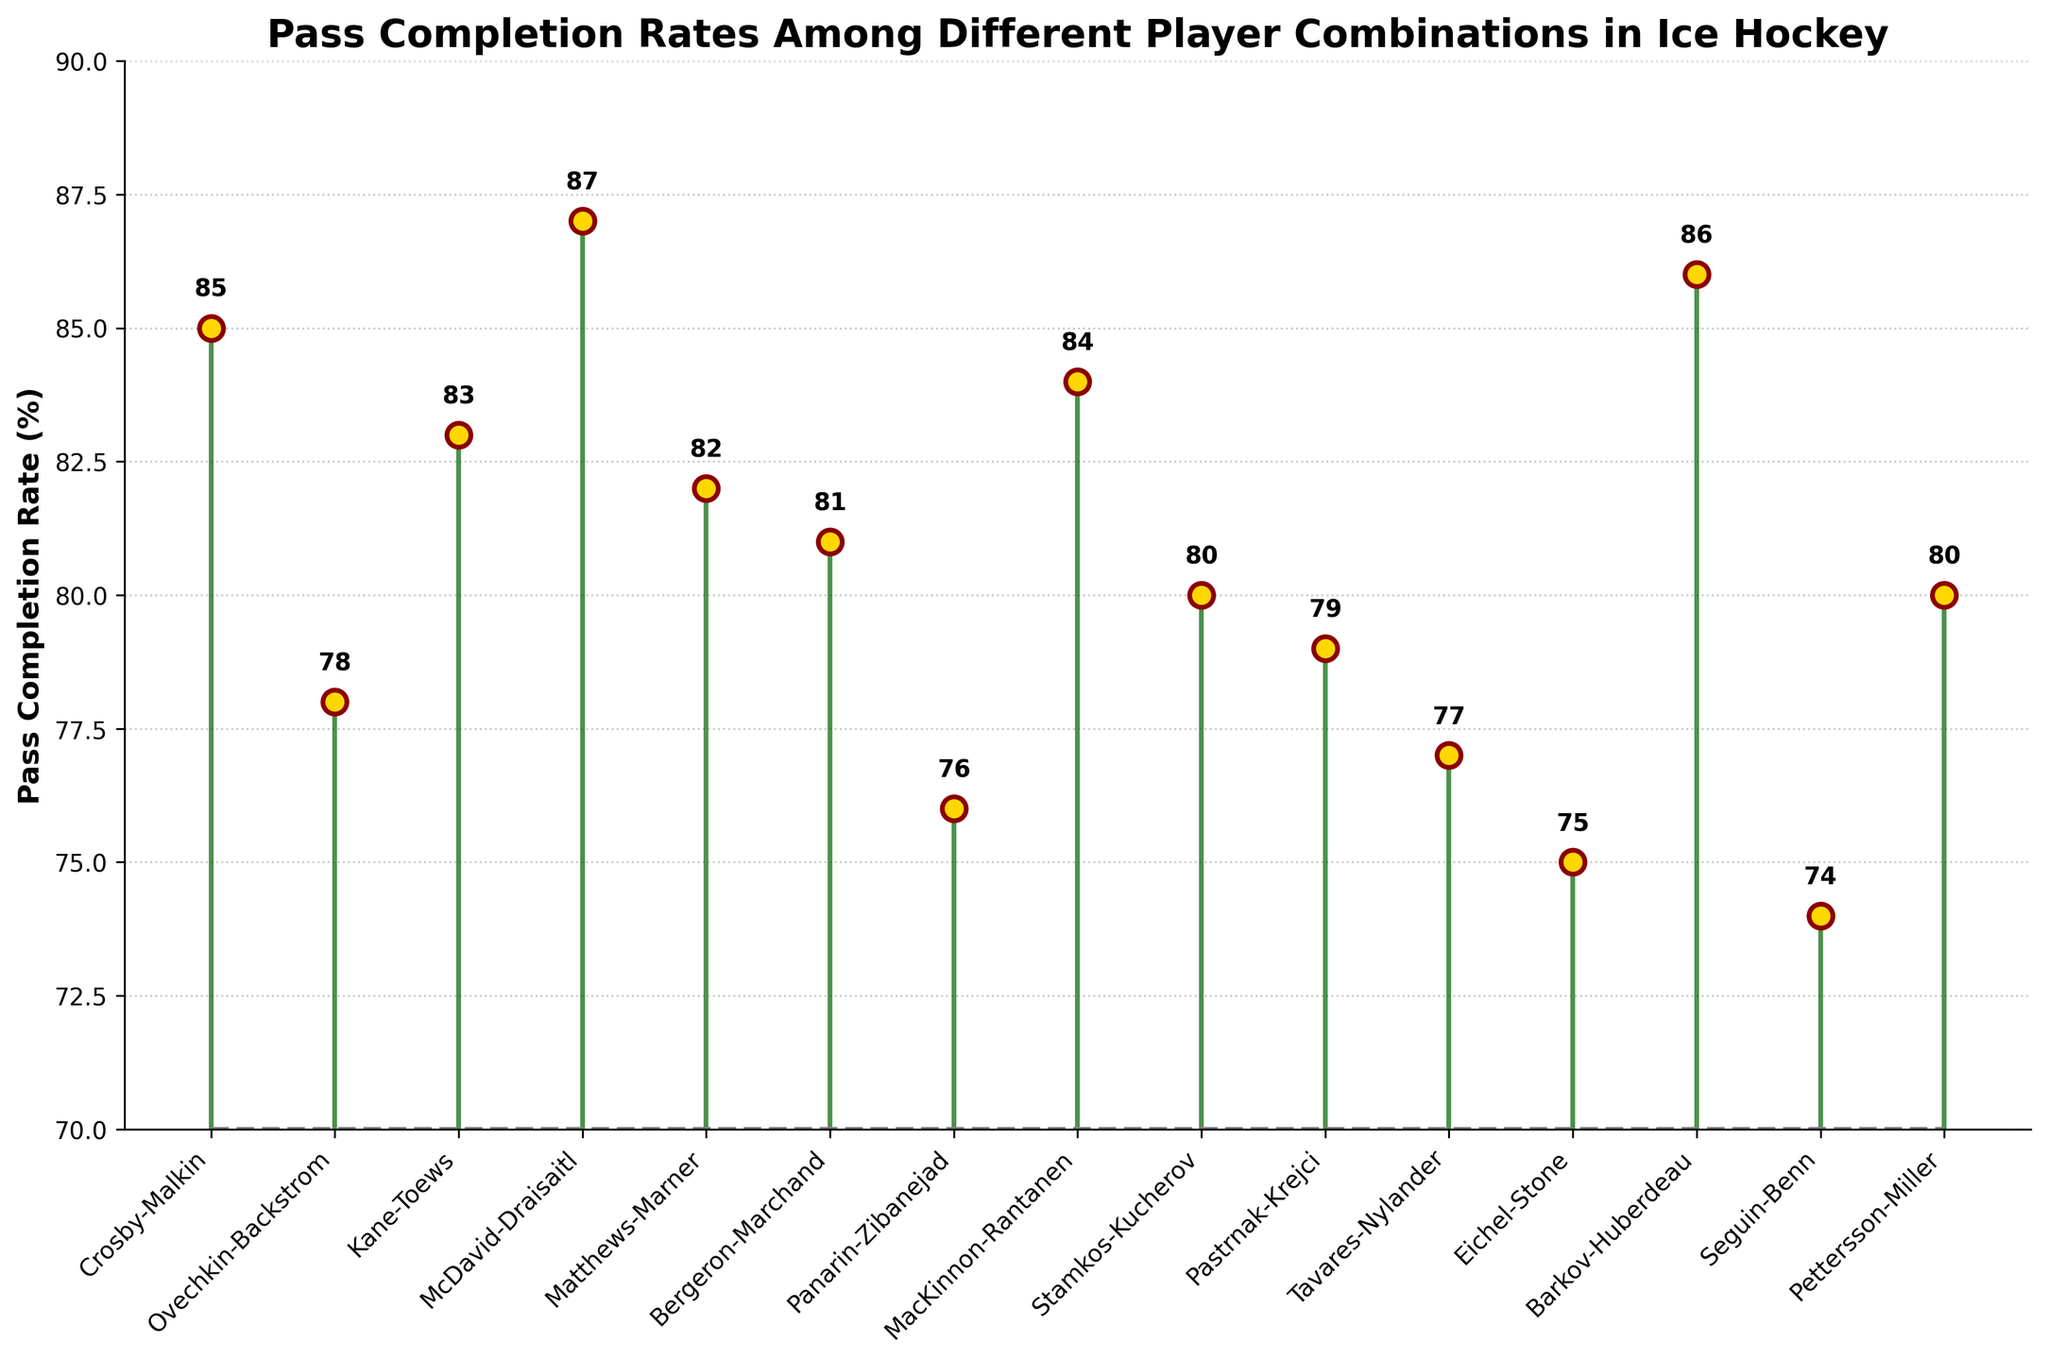How many player combinations have a pass completion rate above 80%? Look at the bars that extend above the 80% mark on the y-axis. Count the corresponding player combinations.
Answer: 10 Which player combination has the highest pass completion rate? Identify the tallest stem line. The top of the tallest stem line corresponds to the player combination with the highest value.
Answer: McDavid-Draisaitl What is the difference in pass completion rate between McDavid-Draisaitl and Seguin-Benn? Find the pass completion rate for McDavid-Draisaitl (87%) and Seguin-Benn (74%). Subtract Seguin-Benn's rate from McDavid-Draisaitl's rate (87 - 74).
Answer: 13 Compare the pass completion rates between Crosby-Malkin and Ovechkin-Backstrom. Which is higher? Find the values on the y-axis for both Crosby-Malkin (85%) and Ovechkin-Backstrom (78%). Compare the two values.
Answer: Crosby-Malkin What is the median pass completion rate among all player combinations? To find the median, list all pass completion rates in numerical order: 74, 75, 76, 77, 78, 79, 80, 80, 81, 82, 83, 84, 85, 86, 87. The median is the middle value of this ordered list.
Answer: 80 How many player combinations have a pass completion rate of exactly 80%? Look at the y-axis for the value 80% and count the player combinations at this level: Stamkos-Kucherov and Pettersson-Miller.
Answer: 2 What is the range of the pass completion rates? Find the highest and lowest pass completion rates: McDavid-Draisaitl (87%) and Seguin-Benn (74%). Subtract the lowest rate from the highest rate (87 - 74).
Answer: 13 Which player combination has the lowest pass completion rate? Identify the shortest stem line. The top of the shortest stem line corresponds to the player combination with the lowest value.
Answer: Seguin-Benn What is the average pass completion rate of all the player combinations? Add all the completion rates (85 + 78 + 83 + 87 + 82 + 81 + 76 + 84 + 80 + 79 + 77 + 75 + 86 + 74 + 80) and divide by the number of combinations (15). The sum is 1167, and the average is 1167/15.
Answer: 77.8 How does the pass completion rate of Matthews-Marner compare to that of Kane-Toews? Find the values on the y-axis for Matthews-Marner (82%) and Kane-Toews (83%). Compare the two values.
Answer: Kane-Toews 